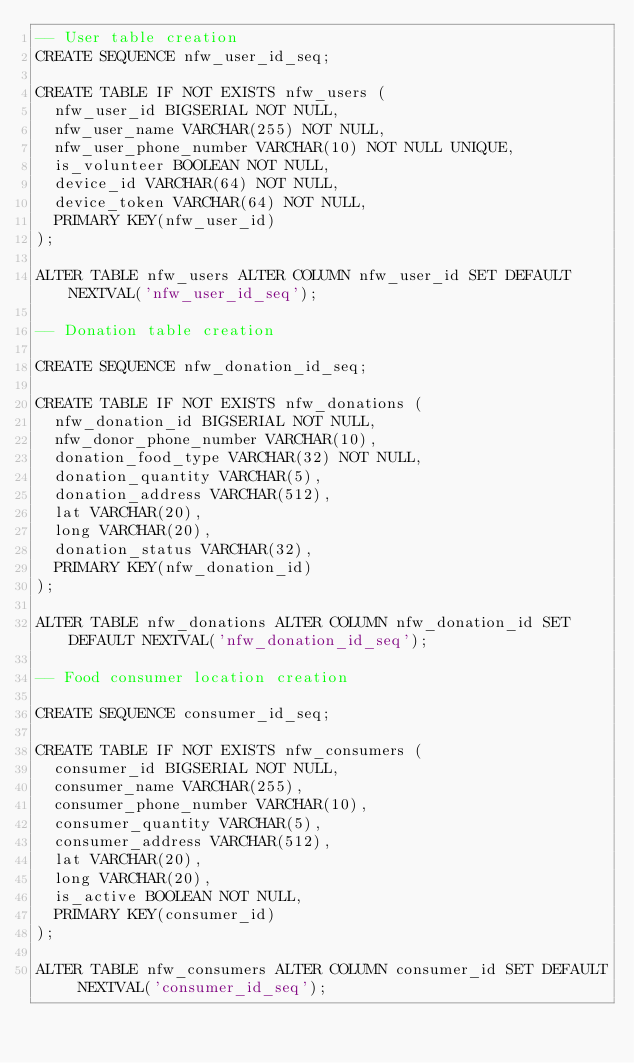Convert code to text. <code><loc_0><loc_0><loc_500><loc_500><_SQL_>-- User table creation
CREATE SEQUENCE nfw_user_id_seq;

CREATE TABLE IF NOT EXISTS nfw_users (
  nfw_user_id BIGSERIAL NOT NULL,
  nfw_user_name VARCHAR(255) NOT NULL,
  nfw_user_phone_number VARCHAR(10) NOT NULL UNIQUE,
  is_volunteer BOOLEAN NOT NULL,
  device_id VARCHAR(64) NOT NULL,
  device_token VARCHAR(64) NOT NULL,
  PRIMARY KEY(nfw_user_id)
);

ALTER TABLE nfw_users ALTER COLUMN nfw_user_id SET DEFAULT NEXTVAL('nfw_user_id_seq');

-- Donation table creation

CREATE SEQUENCE nfw_donation_id_seq;

CREATE TABLE IF NOT EXISTS nfw_donations (
  nfw_donation_id BIGSERIAL NOT NULL,
  nfw_donor_phone_number VARCHAR(10),
  donation_food_type VARCHAR(32) NOT NULL,
  donation_quantity VARCHAR(5),
  donation_address VARCHAR(512),
  lat VARCHAR(20),
  long VARCHAR(20),
  donation_status VARCHAR(32),
  PRIMARY KEY(nfw_donation_id)
);

ALTER TABLE nfw_donations ALTER COLUMN nfw_donation_id SET DEFAULT NEXTVAL('nfw_donation_id_seq');

-- Food consumer location creation

CREATE SEQUENCE consumer_id_seq;

CREATE TABLE IF NOT EXISTS nfw_consumers (
  consumer_id BIGSERIAL NOT NULL,
  consumer_name VARCHAR(255),
  consumer_phone_number VARCHAR(10),
  consumer_quantity VARCHAR(5),
  consumer_address VARCHAR(512),
  lat VARCHAR(20),
  long VARCHAR(20),
  is_active BOOLEAN NOT NULL,
  PRIMARY KEY(consumer_id)
);

ALTER TABLE nfw_consumers ALTER COLUMN consumer_id SET DEFAULT NEXTVAL('consumer_id_seq');</code> 